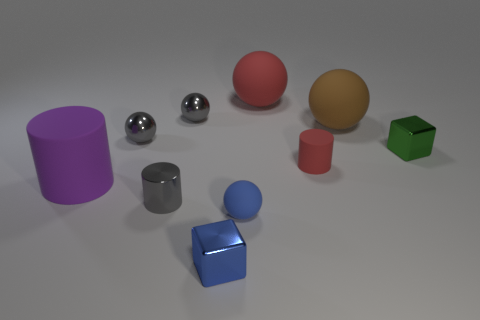There is a tiny matte object that is right of the matte ball in front of the big purple cylinder; what is its color?
Ensure brevity in your answer.  Red. Do the brown sphere and the purple object have the same size?
Provide a short and direct response. Yes. There is a large matte thing that is behind the tiny red thing and to the left of the big brown matte ball; what color is it?
Your response must be concise. Red. What is the size of the purple thing?
Provide a short and direct response. Large. There is a metal cube that is left of the tiny blue rubber object; is it the same color as the tiny rubber sphere?
Keep it short and to the point. Yes. Are there more purple rubber cylinders that are to the right of the brown sphere than tiny blue spheres on the left side of the purple thing?
Offer a very short reply. No. Are there more purple rubber cylinders than big rubber spheres?
Keep it short and to the point. No. There is a sphere that is both to the right of the blue matte object and behind the brown thing; what size is it?
Ensure brevity in your answer.  Large. What is the shape of the purple object?
Keep it short and to the point. Cylinder. Are there any other things that have the same size as the red rubber cylinder?
Keep it short and to the point. Yes. 